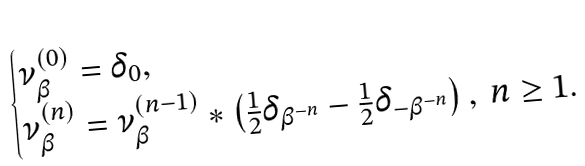Convert formula to latex. <formula><loc_0><loc_0><loc_500><loc_500>\begin{cases} \nu _ { \beta } ^ { ( 0 ) } = \delta _ { 0 } , \\ \nu _ { \beta } ^ { ( n ) } = \nu _ { \beta } ^ { ( n - 1 ) } * \left ( \frac { 1 } { 2 } \delta _ { \beta ^ { - n } } - \frac { 1 } { 2 } \delta _ { - \beta ^ { - n } } \right ) , \ n \geq 1 . \end{cases}</formula> 